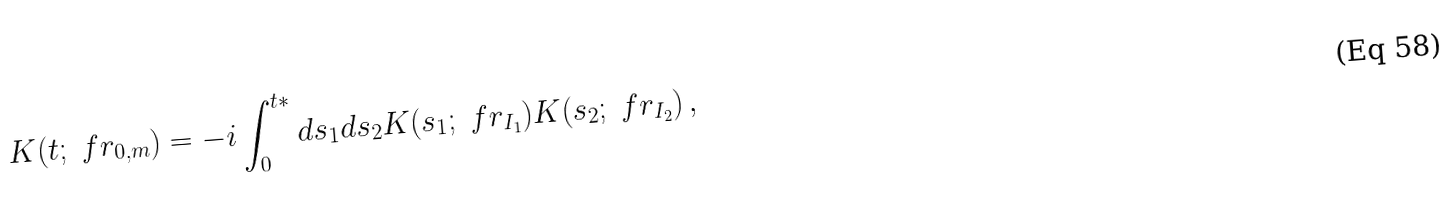<formula> <loc_0><loc_0><loc_500><loc_500>K ( t ; \ f r _ { 0 , m } ) = - i \int ^ { t * } _ { 0 } d s _ { 1 } d s _ { 2 } K ( s _ { 1 } ; \ f r _ { I _ { 1 } } ) K ( s _ { 2 } ; \ f r _ { I _ { 2 } } ) \, ,</formula> 